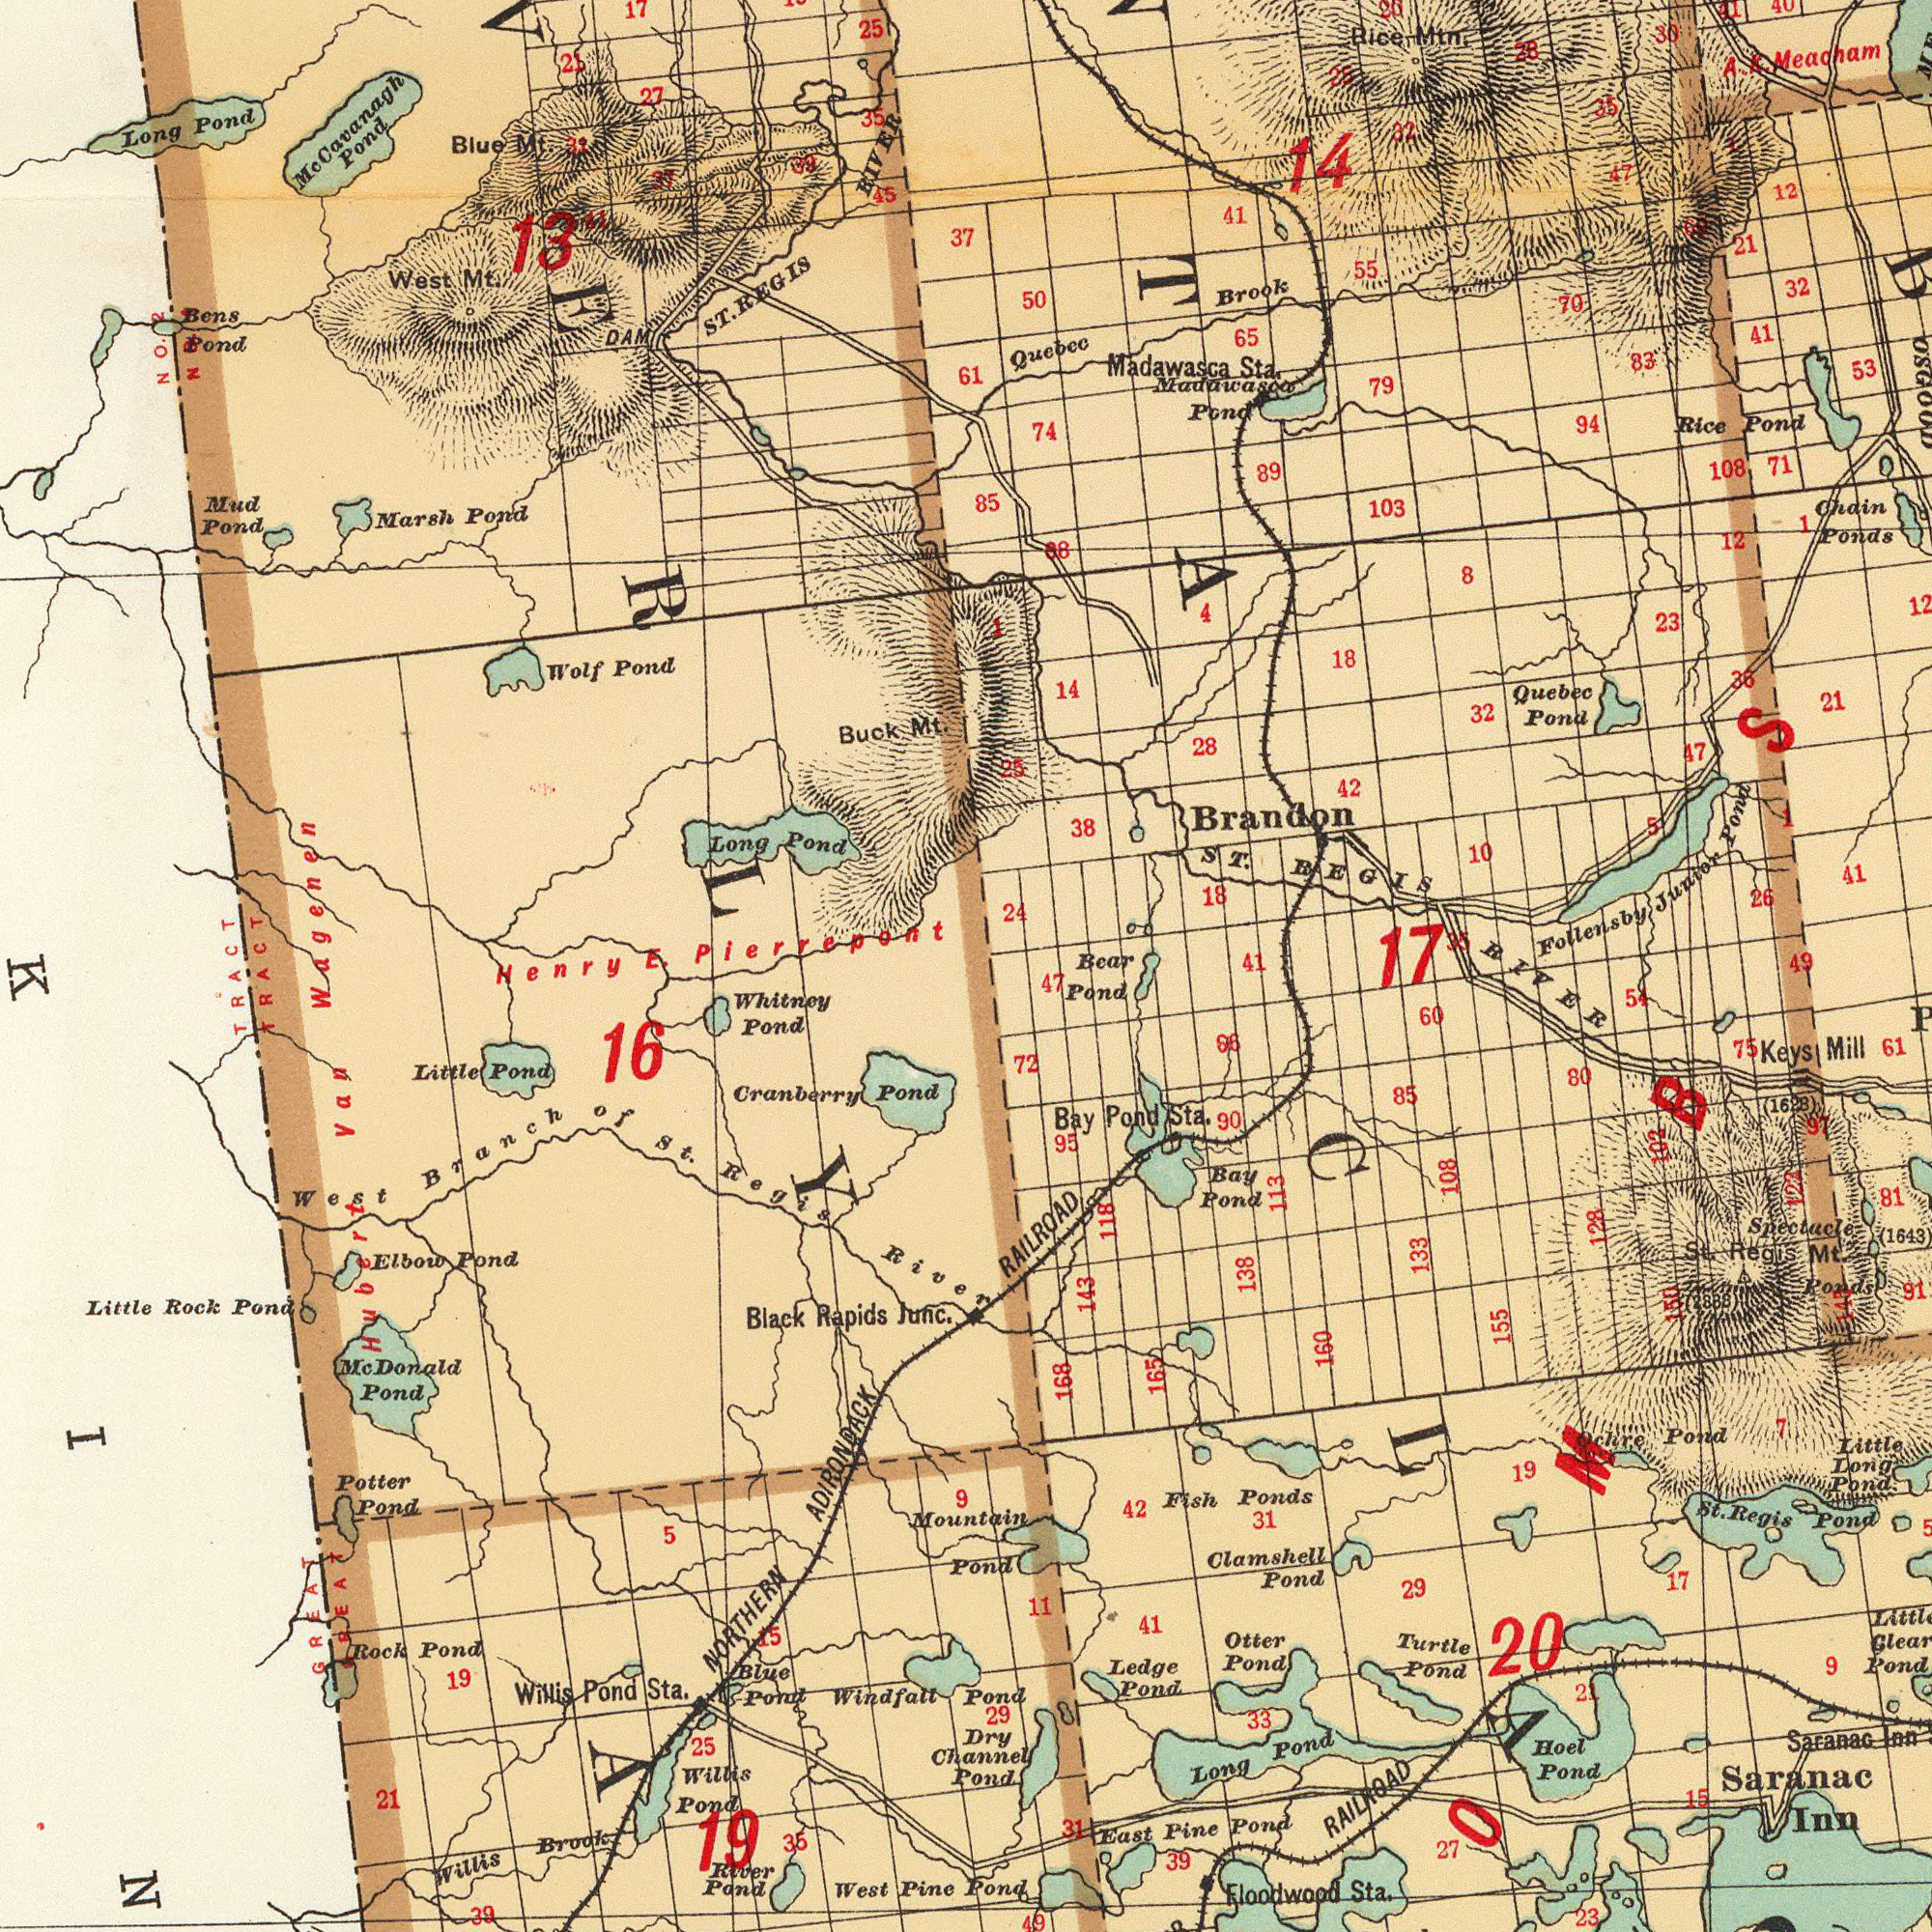What text is visible in the lower-left corner? Henry Cranberry Pond NORTHERN ADIRONDACK West Branch of St. Regis River Willis Brook Black Rapids Junc. Little Pond Windfall Pond Potter Pond Rock Pond Willis Pond West Pine Pond Elbow Pond 19 Willis Pond Sta. Hubert Van Blue Pond 25 Whitney Pond River Pond Little Rock Pond 21 TRACT 39 Mountain Pond 35 5 Mc. Donald Pond 16 TRACT 15 GREAT Dry Channel Pond 29 19 9 GREAT What text can you see in the top-left section? Long Pond West Mt. Long Pond Buck Mt. Blue Mt. 27 Marsh Pond E. Pierrepont 25 ST. REGIS RIVER Wolf Pond Mud Pond Bens Pond 13 McCavanagh Pond DAM 37 45 35 21 17 31 85 61 37 39 1 11 No.2 No.2 Wagenen What text is visible in the lower-right corner? RIVER Pond RAILROAD Saranac Inn Spectacle Ponds Saranac Inn Fish Ponds Floodwood Sta. RAILROAD East Pine Pond Ledge Pond 155 Hoel Pond Bay Pond Clamshell Pond Little Long Pond 143 168 Little Pond Turtle Pond Long Pond St. Regis Mt. 19 85 Bay Pond Sta. Otter Pond 42 33 138 27 61 39 11 7 St. Regis Pond 72 17 Keys Mill 41 81 80 113 90 31 60 23 54 29 133 118 102 128 15 95 91 (1628) 31 75 21 160 (1643) 165 47 Ocher Pond 49 20 9 86 108 150 (2888) 143 123 97 What text is shown in the top-right quadrant? Brandon ST. BEGIS 14 Follensby Junior Pond 18 Madawasca Sta. Rice Pond 53 Quebec Brook Chain Ponds 103 A. K. Meacham 32 26 32 21 41 21 10 28 18 23 Rice Mtn 50 12 71 30 Quebec Pond 47 42 108 94 55 38 88 79 65 12 14 83 28 74 24 41 89 5 Madawasa Pond 41 Bear 70 8 36 32 25 35 47 40 25 20 41 1 1 1 49 17 35 4 41 